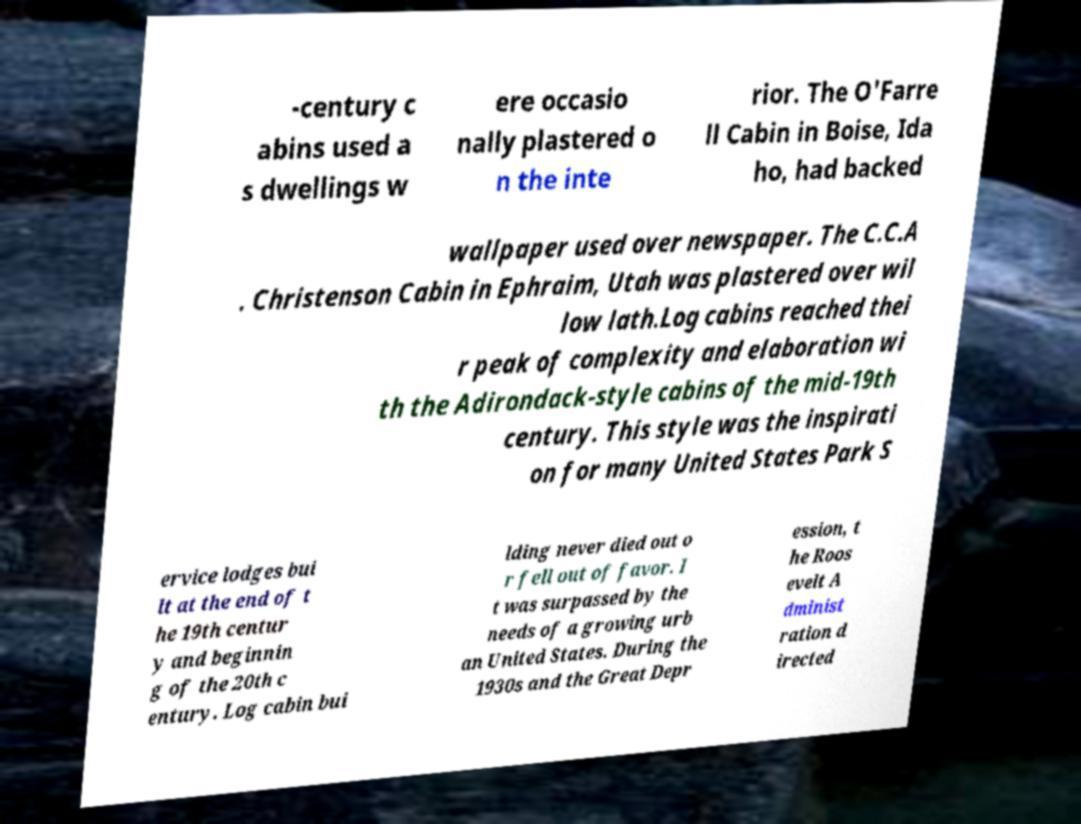There's text embedded in this image that I need extracted. Can you transcribe it verbatim? -century c abins used a s dwellings w ere occasio nally plastered o n the inte rior. The O'Farre ll Cabin in Boise, Ida ho, had backed wallpaper used over newspaper. The C.C.A . Christenson Cabin in Ephraim, Utah was plastered over wil low lath.Log cabins reached thei r peak of complexity and elaboration wi th the Adirondack-style cabins of the mid-19th century. This style was the inspirati on for many United States Park S ervice lodges bui lt at the end of t he 19th centur y and beginnin g of the 20th c entury. Log cabin bui lding never died out o r fell out of favor. I t was surpassed by the needs of a growing urb an United States. During the 1930s and the Great Depr ession, t he Roos evelt A dminist ration d irected 